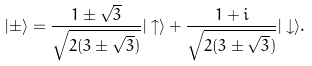<formula> <loc_0><loc_0><loc_500><loc_500>| \pm \rangle = \frac { 1 \pm \sqrt { 3 } } { \sqrt { 2 ( 3 \pm \sqrt { 3 } ) } } | \uparrow \rangle + \frac { 1 + i } { \sqrt { 2 ( 3 \pm \sqrt { 3 } ) } } | \downarrow \rangle .</formula> 